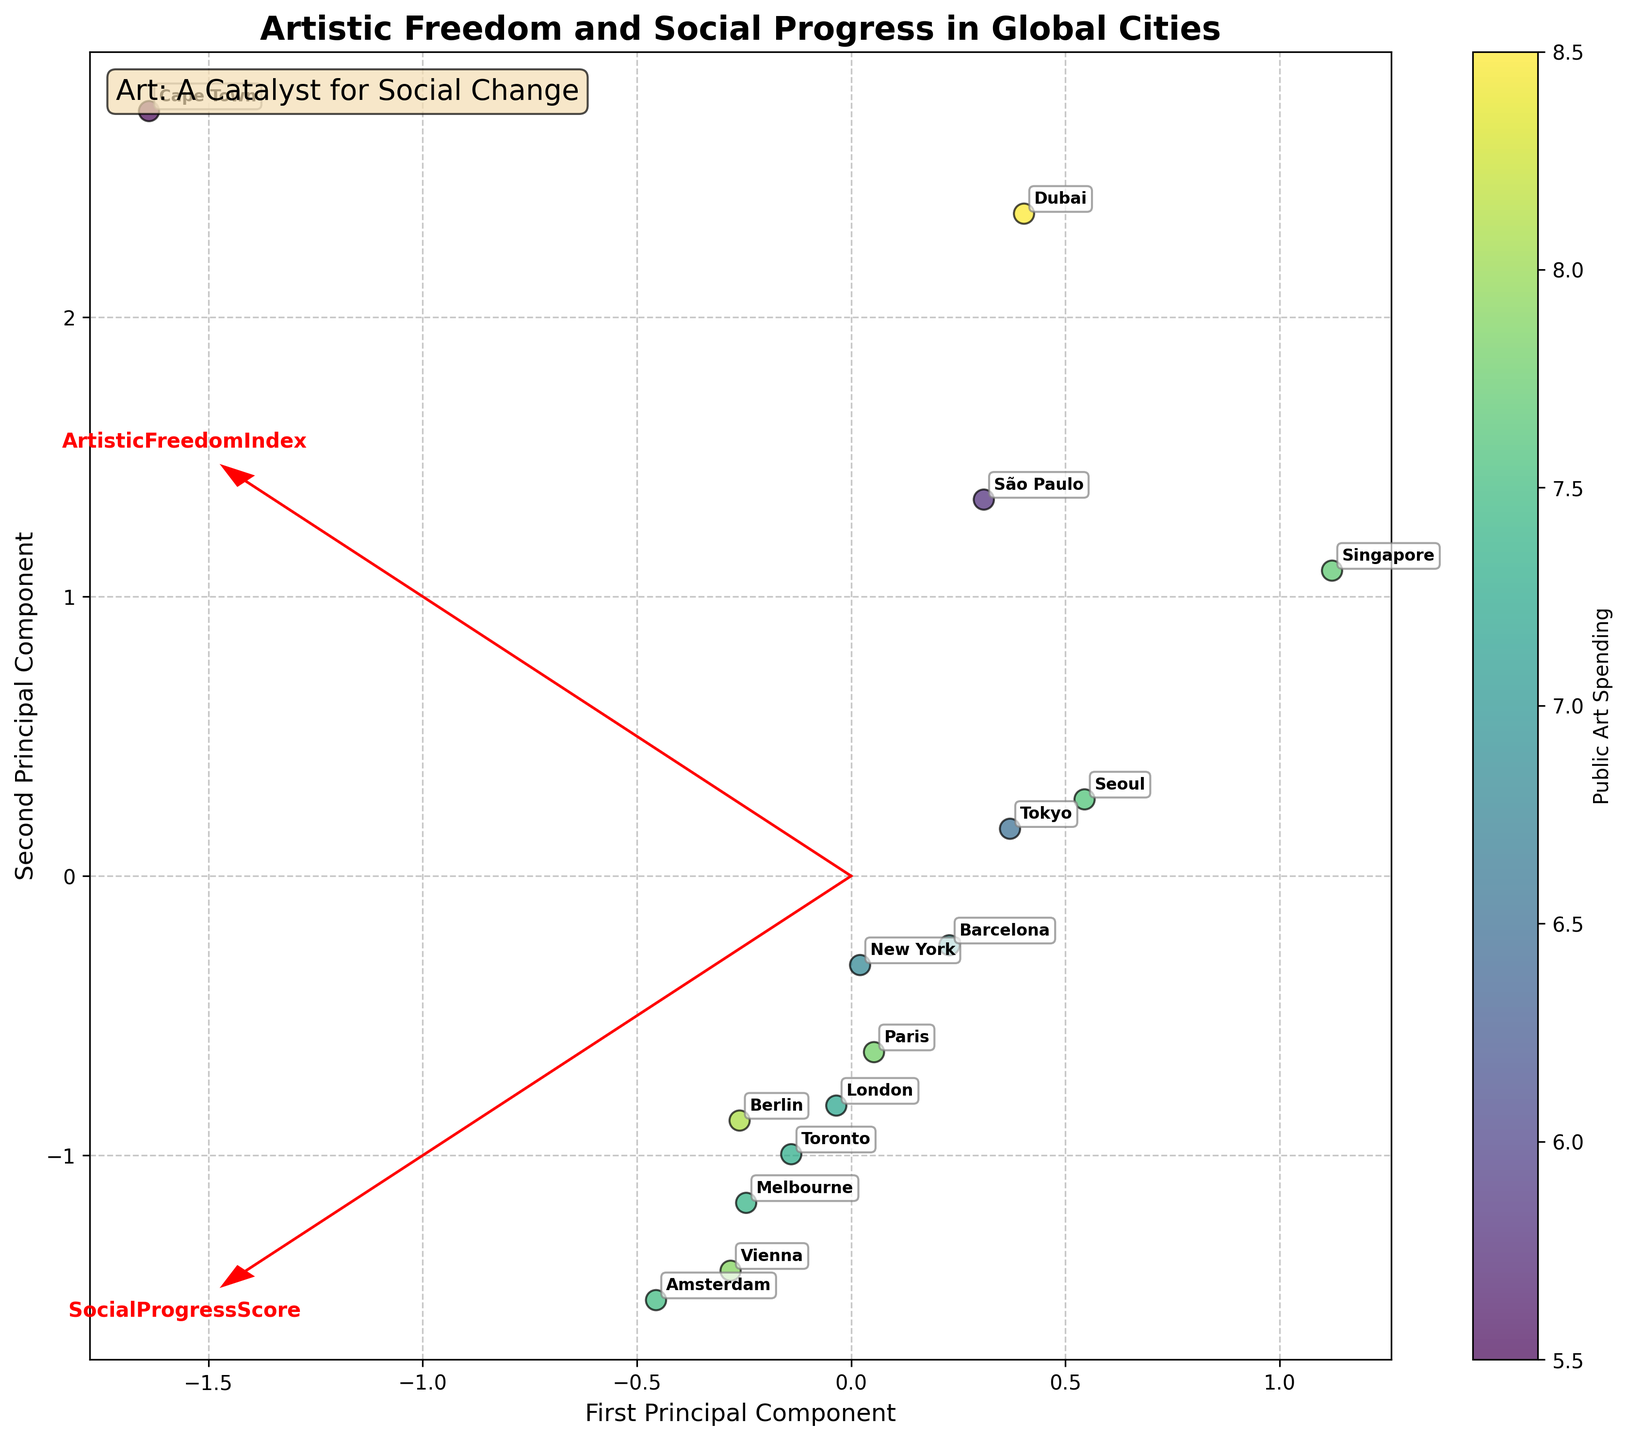How many cities are represented in the biplot? To find the number of cities represented in the biplot, we can count the labeled points. There are 15 unique labels corresponding to different cities.
Answer: 15 What is the title of the biplot? The title of the biplot is displayed at the top of the figure. It reads "Artistic Freedom and Social Progress in Global Cities".
Answer: Artistic Freedom and Social Progress in Global Cities Which city has the highest Public Art Spending as visualized by the color gradient? The color gradient represents Public Art Spending, with darker colors indicating higher spending. The city with the darkest point is Dubai.
Answer: Dubai Which two feature vectors are displayed in the biplot? Looking at the red arrows in the biplot, they are labeled with "ArtisticFreedomIndex" and "SocialProgressScore", indicating the two feature vectors.
Answer: ArtisticFreedomIndex and SocialProgressScore Does Amsterdam or São Paulo have a higher Social Progress Score? From the labels, we can see that Amsterdam's point is positioned further along the Social Progress Score feature vector compared to São Paulo's point. Therefore, Amsterdam has a higher Social Progress Score.
Answer: Amsterdam Which city has the lowest ArtisticFreedomIndex? Referring to the labels and the direction of the ArtisticFreedomIndex vector, Dubai, at the leftmost position along this vector, has the lowest ArtisticFreedomIndex.
Answer: Dubai How does New York compare to London in terms of ArtisticFreedomIndex and SocialProgressScore? By examining their positions relative to the origin and the feature vectors, New York is closer to both the ArtisticFreedomIndex and SocialProgressScore vectors compared to London. Therefore, New York has lower values for both indices.
Answer: New York is lower Describe the relationship between Vienna and Paris in terms of their placement in the biplot. Vienna and Paris appear near each other and both are on an average placement relative to the ArtisticFreedomIndex and SocialProgressScore vectors. This suggests they have similar scores for these indices.
Answer: Similar scores How do cities with relatively high Cultural Policy Ratings generally appear on the biplot? Although Cultural Policy Rating is not directly plotted, related cities like Amsterdam, Berlin, and Vienna (known for high ratings) appear clustered together with high ArtisticFreedomIndex and SocialProgressScore, suggesting a potential correlation.
Answer: Clustered together What is the overall message conveyed by the text box in the biplot? The text box at the top left conveys an artistic message: "Art: A Catalyst for Social Change," suggesting the importance of art in driving societal progress.
Answer: Art: A Catalyst for Social Change 